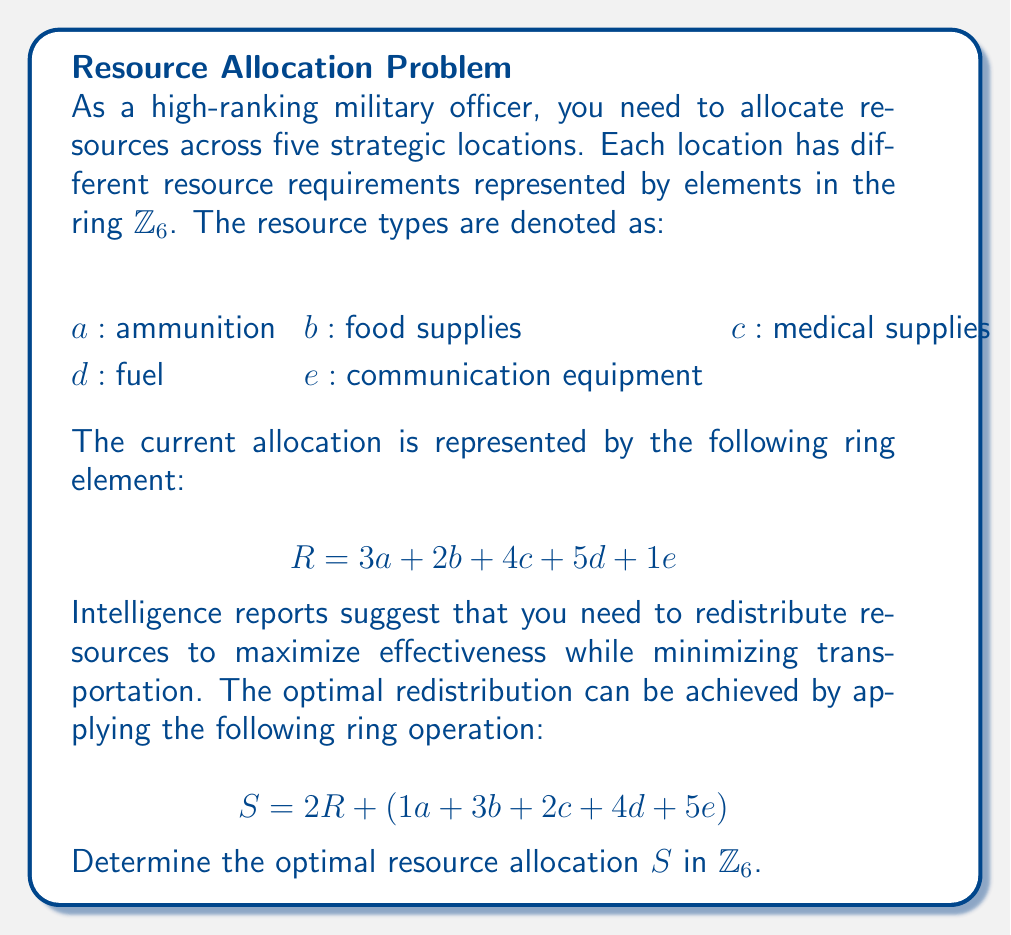Help me with this question. Let's approach this step-by-step:

1) First, we need to calculate $2R$:
   $$2R = 2(3a + 2b + 4c + 5d + 1e)$$
   $$= 6a + 4b + 8c + 10d + 2e$$

2) In $\mathbb{Z}_6$, we need to reduce these coefficients modulo 6:
   $$2R = 0a + 4b + 2c + 4d + 2e$$

3) Now, we add this result to $(1a + 3b + 2c + 4d + 5e)$:
   $$(0a + 4b + 2c + 4d + 2e) + (1a + 3b + 2c + 4d + 5e)$$

4) We perform the addition in $\mathbb{Z}_6$:
   $$a: 0 + 1 = 1$$
   $$b: 4 + 3 = 1$$
   $$c: 2 + 2 = 4$$
   $$d: 4 + 4 = 2$$
   $$e: 2 + 5 = 1$$

5) Therefore, the optimal resource allocation $S$ is:
   $$S = 1a + 1b + 4c + 2d + 1e$$

This result represents the optimal redistribution of resources across the five strategic locations, taking into account the initial allocation and the intelligence reports.
Answer: $S = 1a + 1b + 4c + 2d + 1e$ in $\mathbb{Z}_6$ 